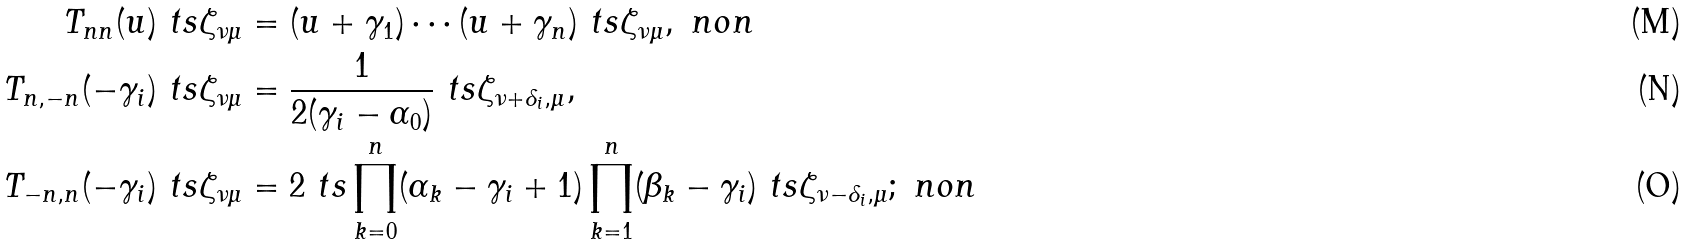<formula> <loc_0><loc_0><loc_500><loc_500>T _ { n n } ( u ) \ t s \zeta _ { \nu \mu } & = ( u + \gamma _ { 1 } ) \cdots ( u + \gamma _ { n } ) \ t s \zeta _ { \nu \mu } , \ n o n \\ T _ { n , - n } ( - \gamma _ { i } ) \ t s \zeta _ { \nu \mu } & = \frac { 1 } { 2 ( \gamma _ { i } - \alpha _ { 0 } ) } \ t s \zeta _ { \nu + \delta _ { i } , \mu } , \\ T _ { - n , n } ( - \gamma _ { i } ) \ t s \zeta _ { \nu \mu } & = 2 \ t s \prod _ { k = 0 } ^ { n } ( \alpha _ { k } - \gamma _ { i } + 1 ) \prod _ { k = 1 } ^ { n } ( \beta _ { k } - \gamma _ { i } ) \ t s \zeta _ { \nu - \delta _ { i } , \mu } ; \ n o n</formula> 